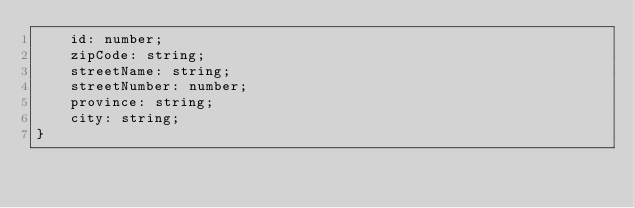<code> <loc_0><loc_0><loc_500><loc_500><_TypeScript_>    id: number;
    zipCode: string;
    streetName: string;
    streetNumber: number;
    province: string;
    city: string;
}
</code> 